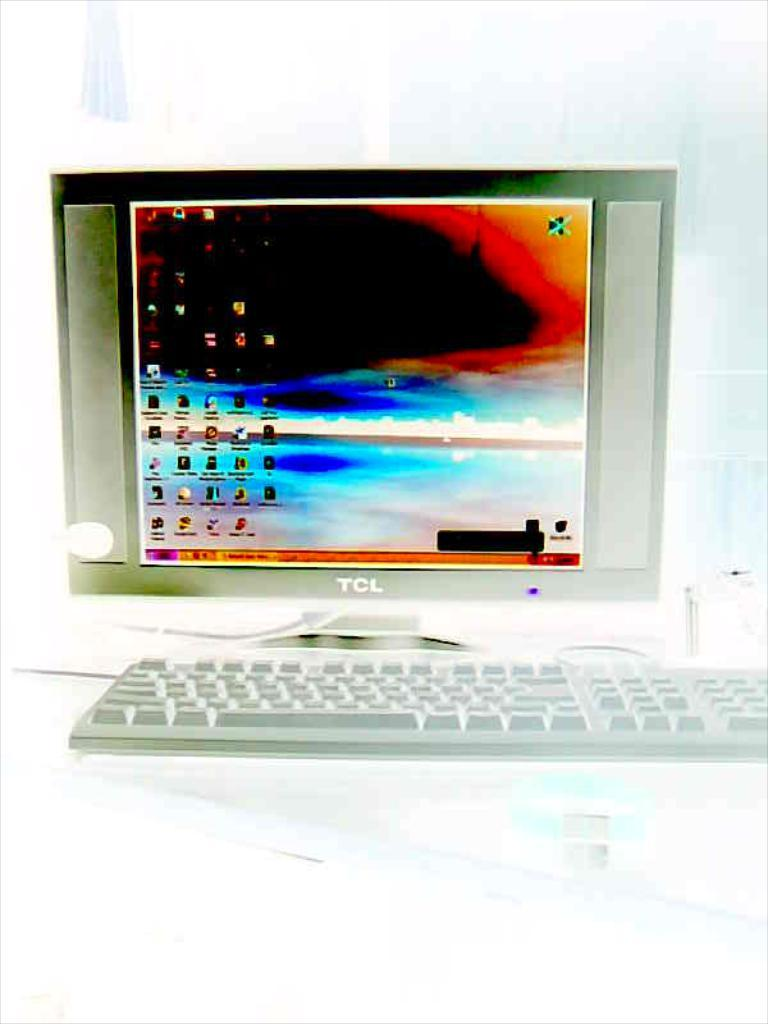Provide a one-sentence caption for the provided image. A TCL monitor has a black hole surrounding by other colors on the screen. 